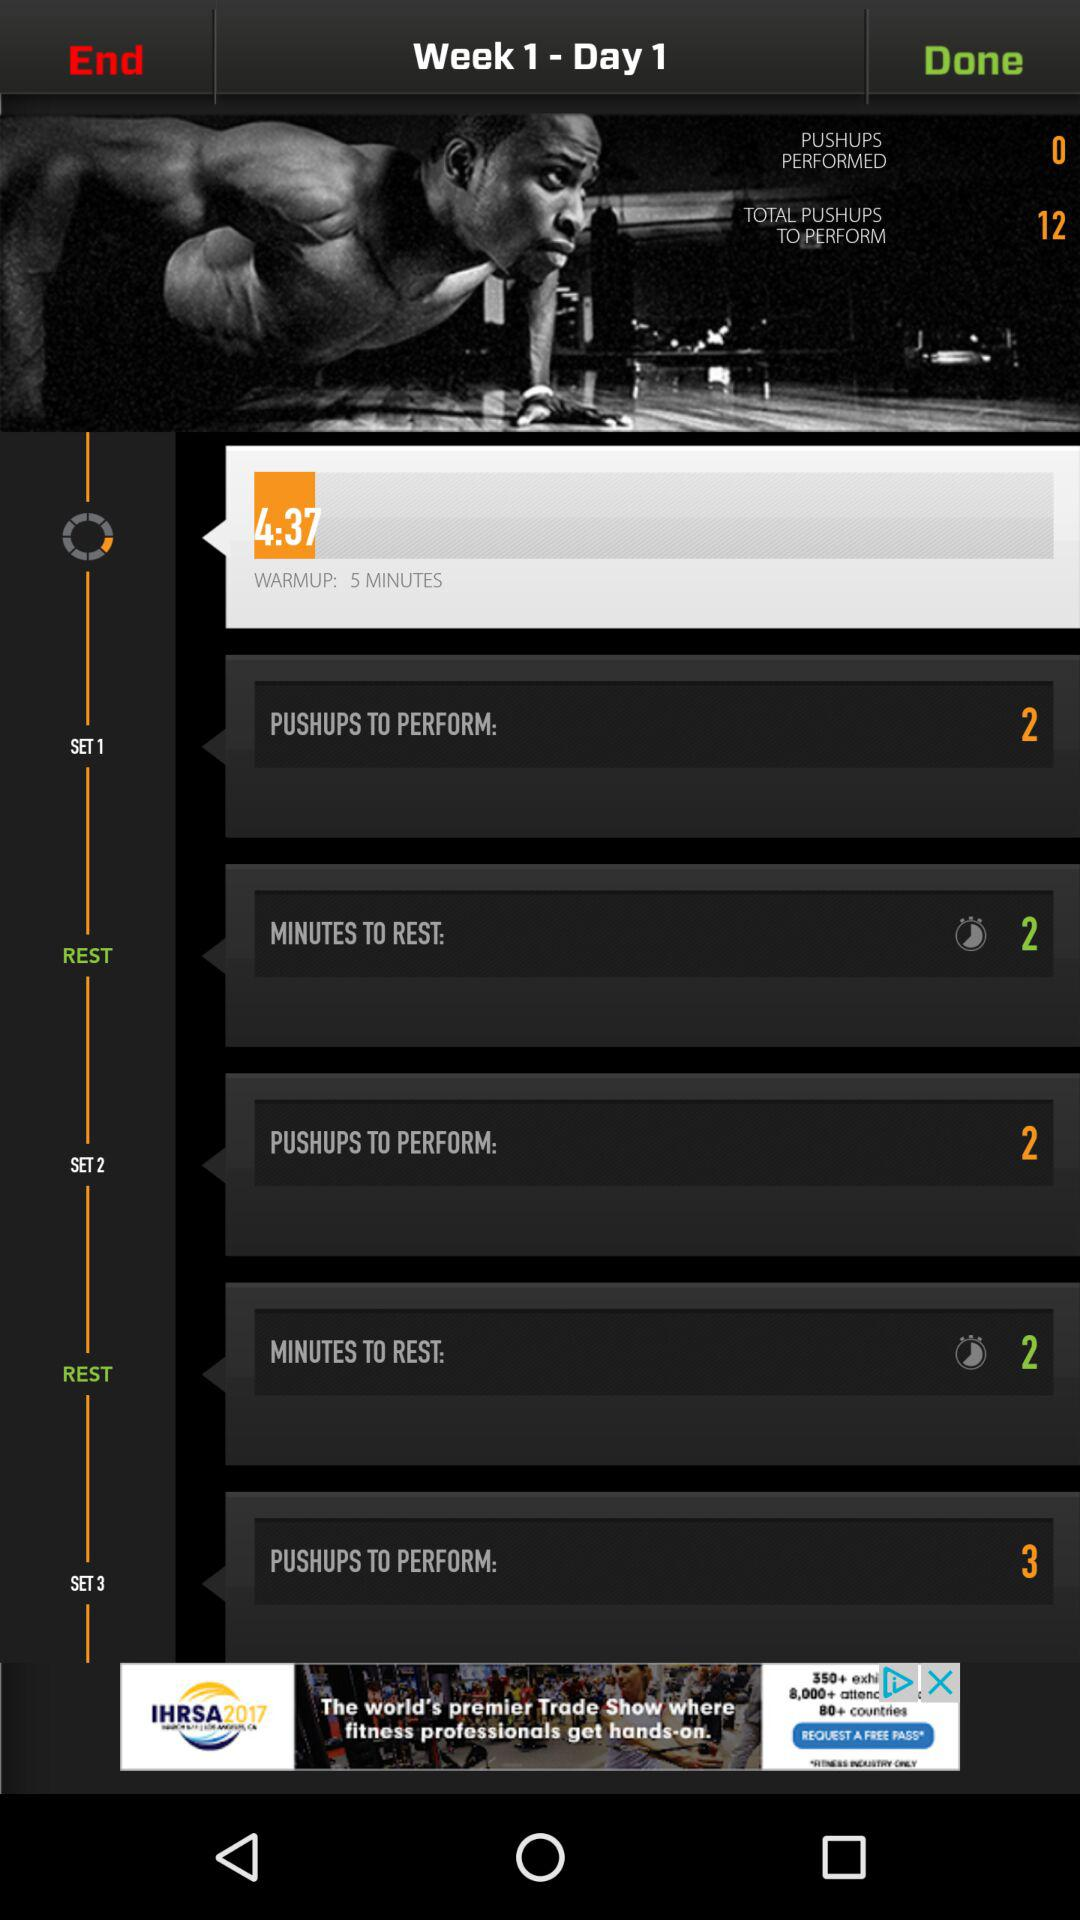How many minutes of rest should be done after every exercise? The rest of 2 minutes should be done after every exercise. 